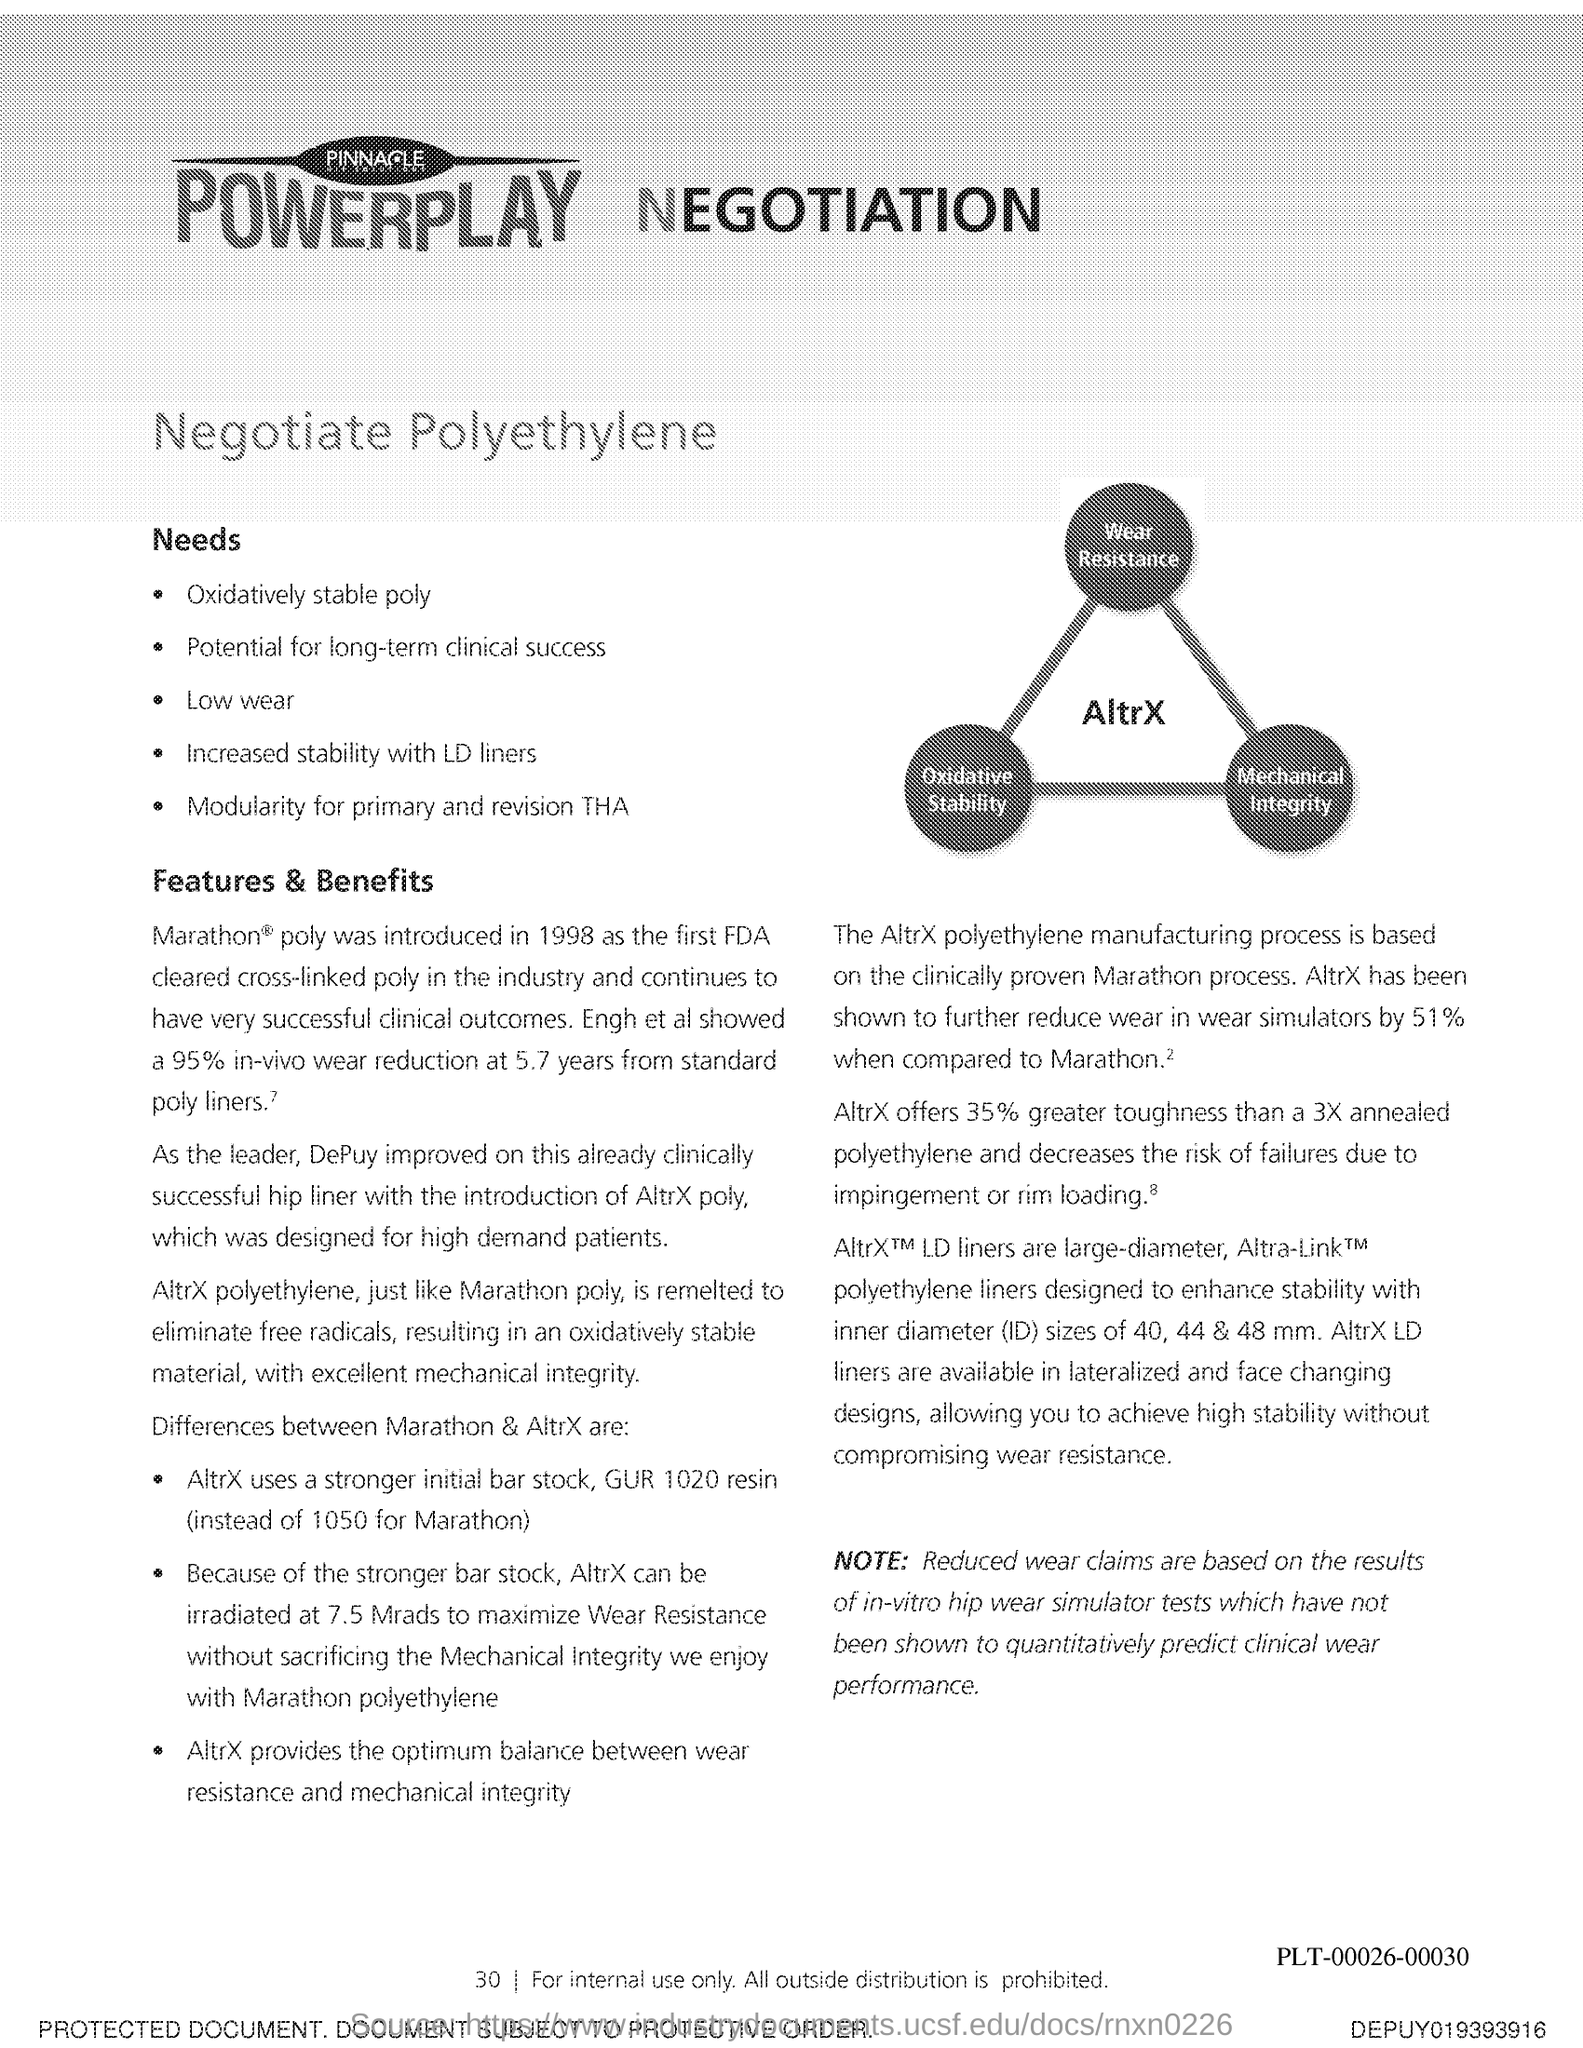Identify some key points in this picture. What is the page number? 30..." is a question asking for information about a specific page number. 